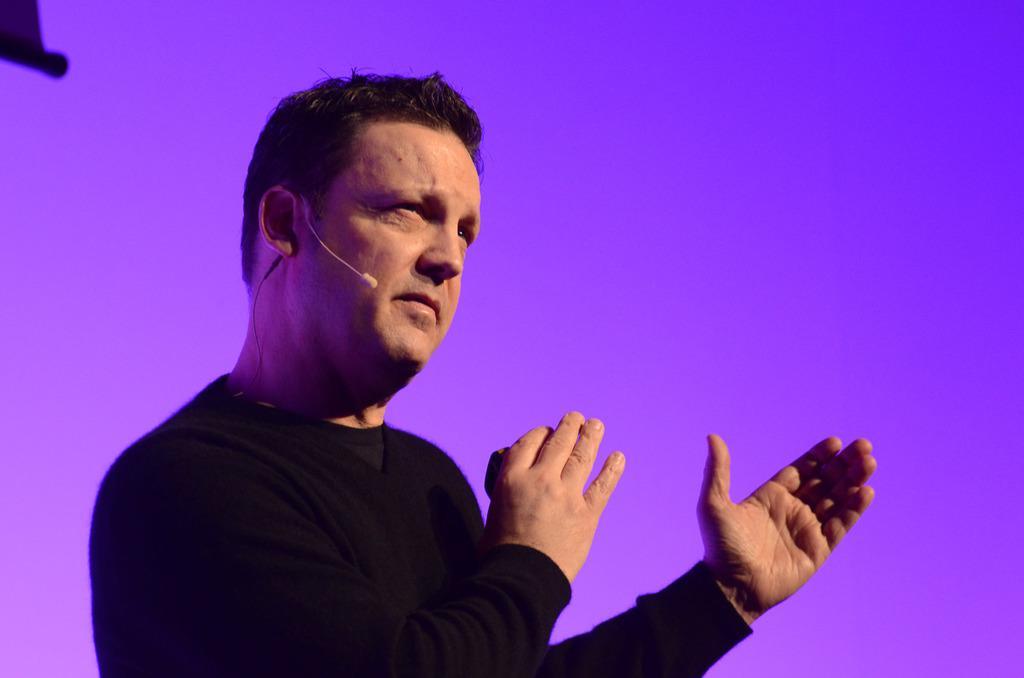Please provide a concise description of this image. In this picture there is a man with black color t-shirt. At the back there is a purple and pink background. At the top left there is an object. 